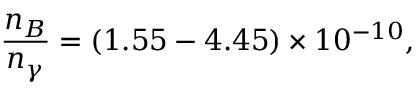Convert formula to latex. <formula><loc_0><loc_0><loc_500><loc_500>\frac { n _ { B } } { n _ { \gamma } } = ( 1 . 5 5 - 4 . 4 5 ) \times 1 0 ^ { - 1 0 } ,</formula> 